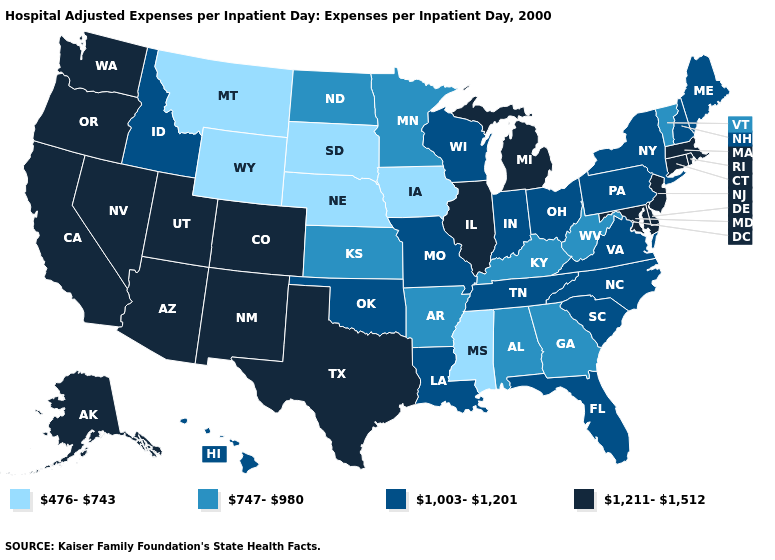What is the highest value in the West ?
Short answer required. 1,211-1,512. Among the states that border New Hampshire , which have the highest value?
Give a very brief answer. Massachusetts. What is the highest value in the South ?
Write a very short answer. 1,211-1,512. What is the lowest value in the USA?
Be succinct. 476-743. What is the highest value in the West ?
Keep it brief. 1,211-1,512. Name the states that have a value in the range 1,211-1,512?
Answer briefly. Alaska, Arizona, California, Colorado, Connecticut, Delaware, Illinois, Maryland, Massachusetts, Michigan, Nevada, New Jersey, New Mexico, Oregon, Rhode Island, Texas, Utah, Washington. Does Florida have the same value as Kentucky?
Give a very brief answer. No. Which states have the lowest value in the MidWest?
Concise answer only. Iowa, Nebraska, South Dakota. Which states have the lowest value in the South?
Write a very short answer. Mississippi. What is the highest value in states that border Maryland?
Write a very short answer. 1,211-1,512. What is the value of Indiana?
Concise answer only. 1,003-1,201. What is the value of Nevada?
Short answer required. 1,211-1,512. What is the value of West Virginia?
Concise answer only. 747-980. Does Florida have the lowest value in the USA?
Keep it brief. No. 